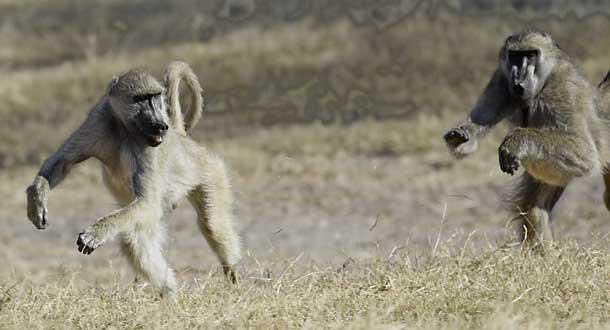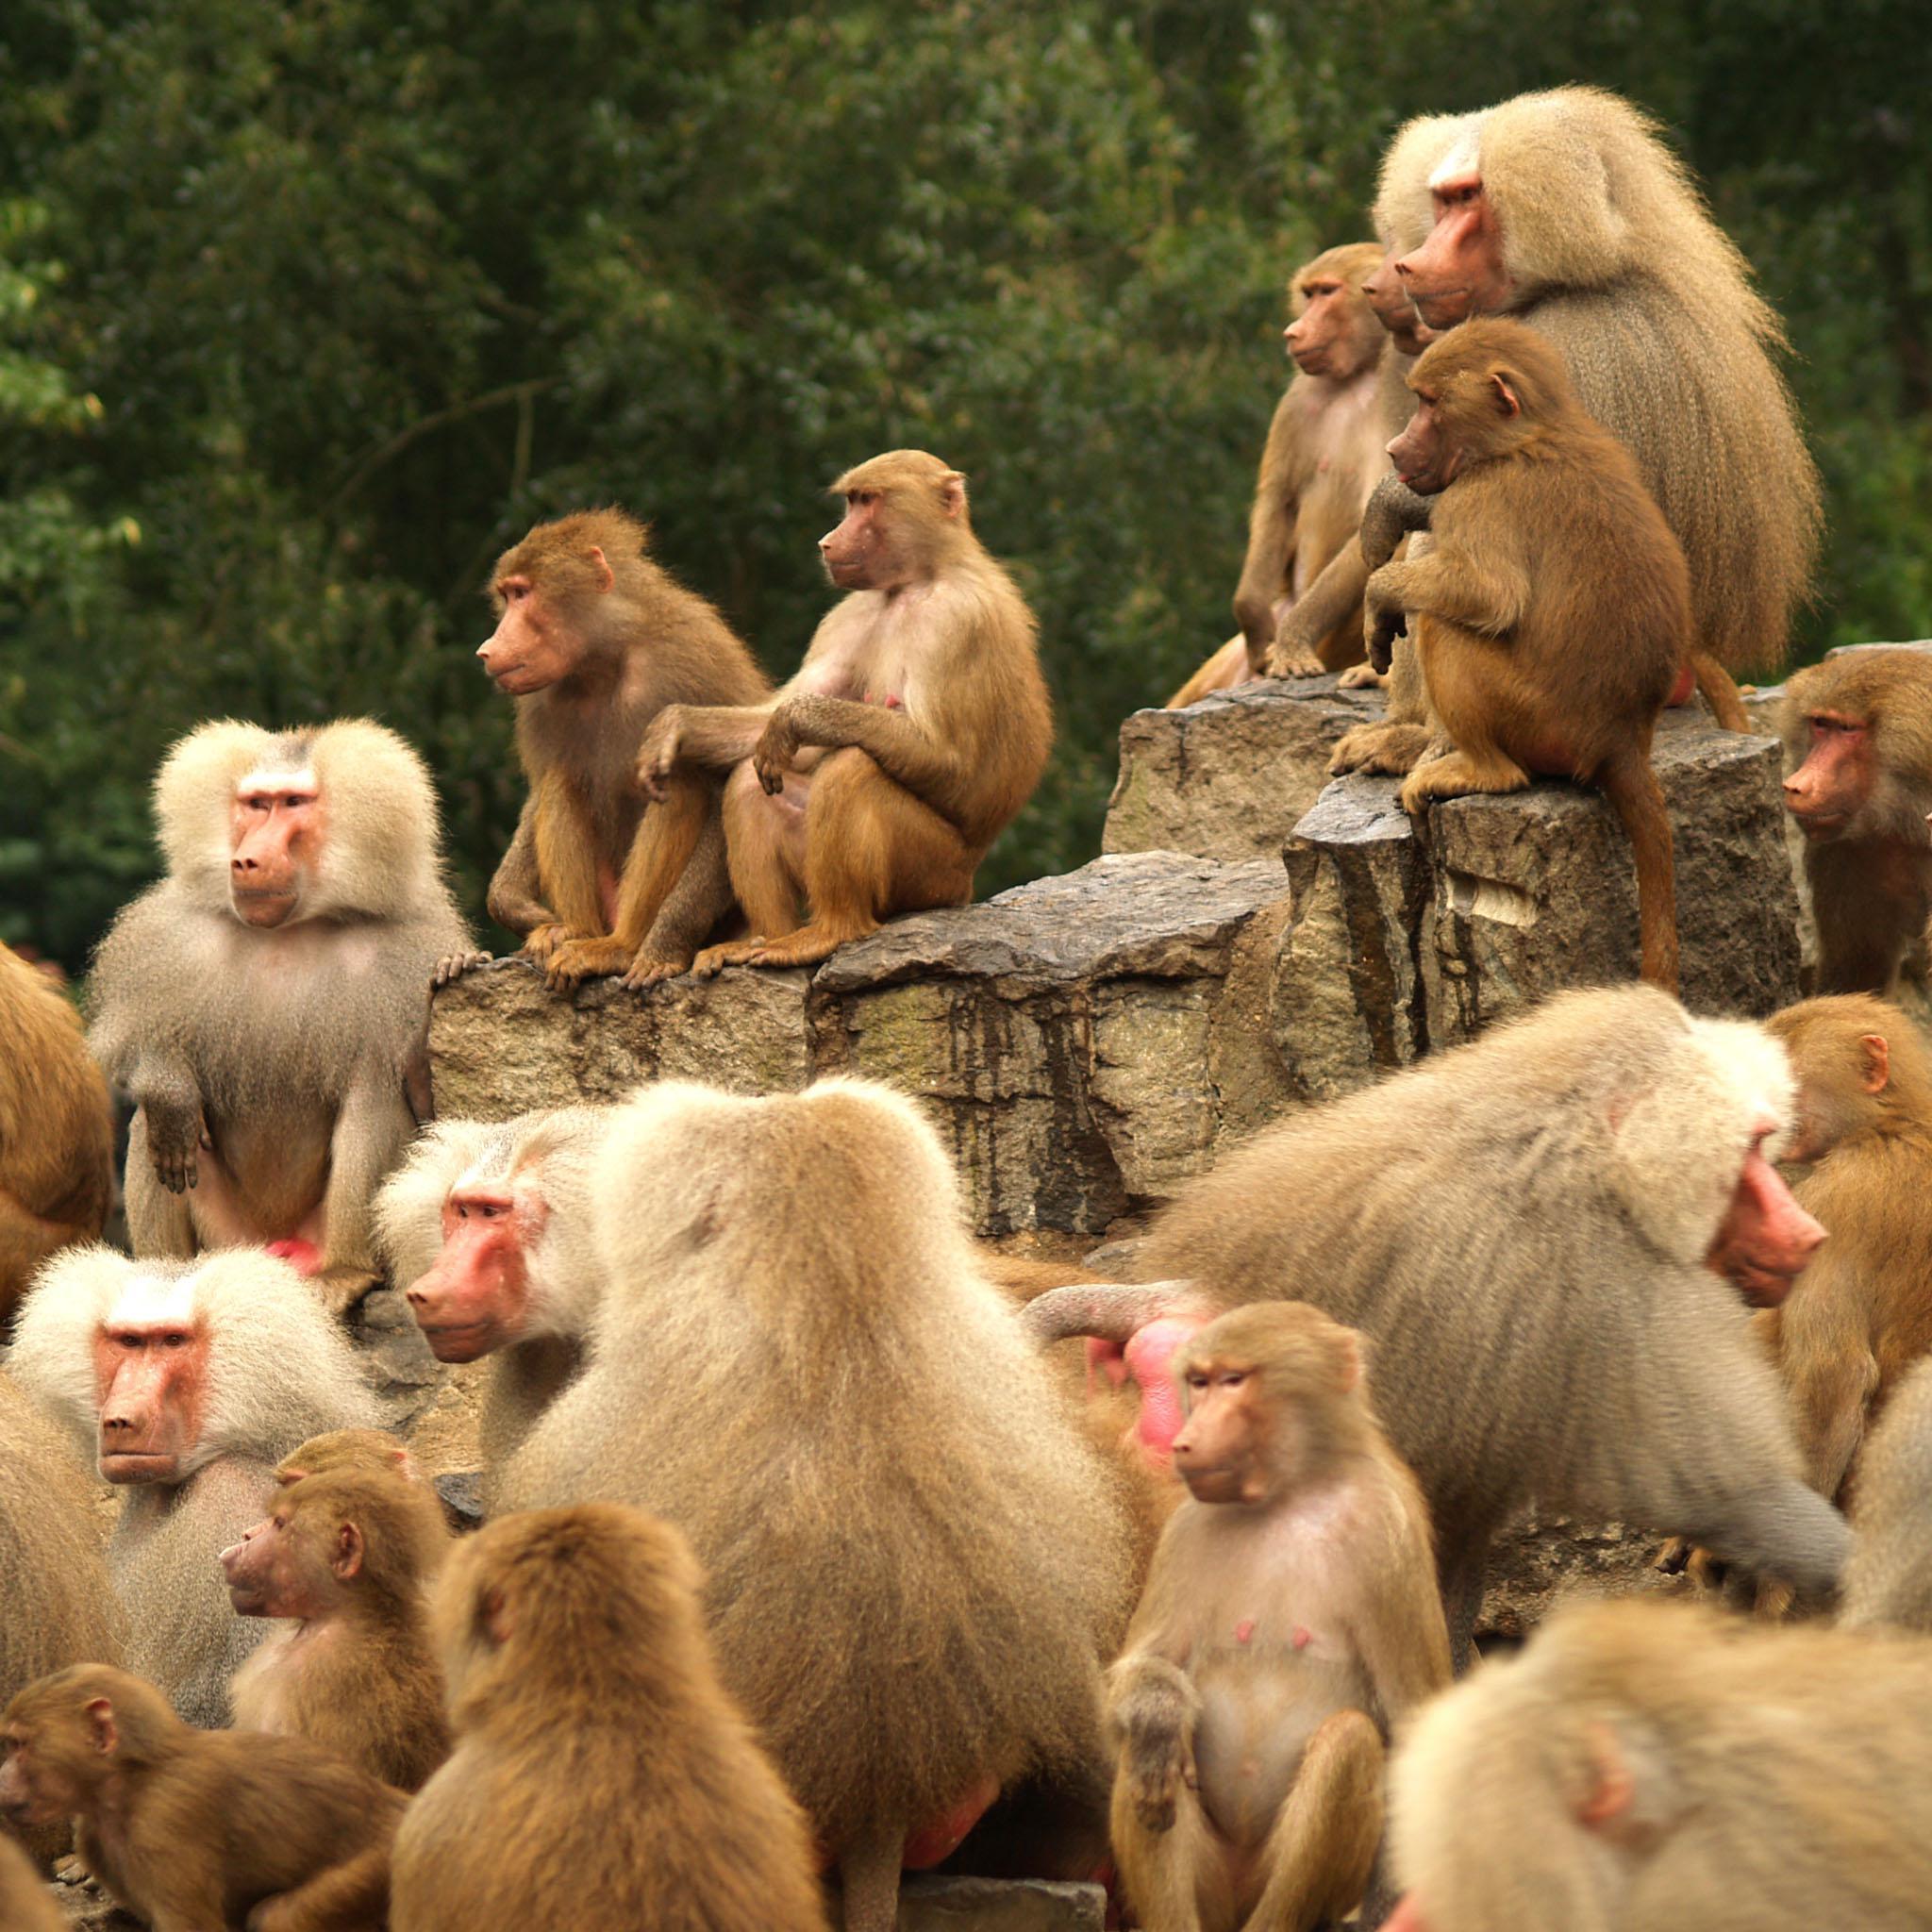The first image is the image on the left, the second image is the image on the right. Examine the images to the left and right. Is the description "One baboon sits with bent knees and its body turned leftward, in an image." accurate? Answer yes or no. No. 